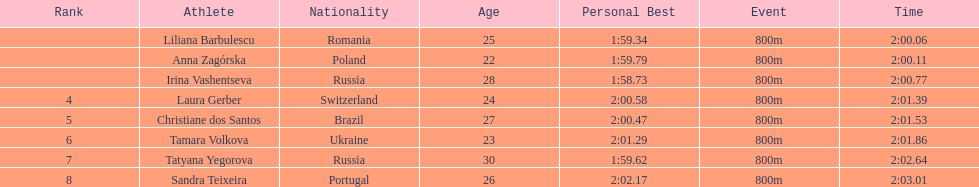Which south american country placed after irina vashentseva? Brazil. 